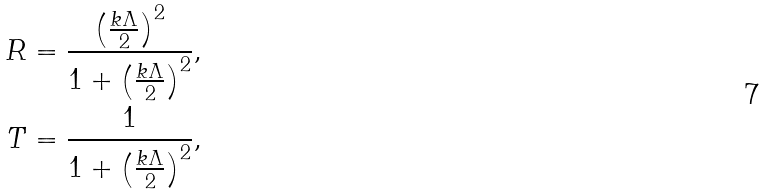<formula> <loc_0><loc_0><loc_500><loc_500>R = \frac { \left ( \frac { k \Lambda } { 2 } \right ) ^ { 2 } } { 1 + \left ( \frac { k \Lambda } { 2 } \right ) ^ { 2 } } , \\ T = \frac { 1 } { 1 + \left ( \frac { k \Lambda } { 2 } \right ) ^ { 2 } } ,</formula> 